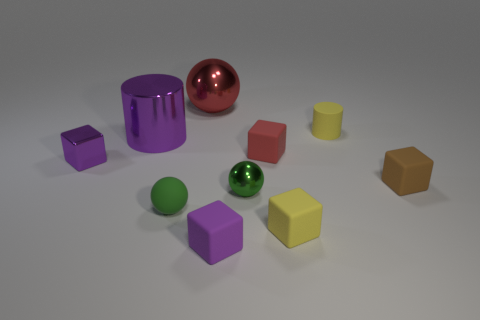What is the thing that is in front of the green rubber sphere and to the right of the red cube made of?
Provide a short and direct response. Rubber. Do the cylinder that is right of the large red metallic thing and the big shiny sphere have the same color?
Make the answer very short. No. Does the rubber cylinder have the same color as the large thing that is behind the small cylinder?
Ensure brevity in your answer.  No. There is a rubber ball; are there any red metal spheres in front of it?
Offer a very short reply. No. Do the small cylinder and the small brown object have the same material?
Your response must be concise. Yes. What material is the cylinder that is the same size as the brown matte thing?
Your answer should be compact. Rubber. How many things are either yellow matte objects that are behind the tiny brown object or large red metallic balls?
Your response must be concise. 2. Is the number of large red spheres behind the rubber ball the same as the number of cylinders?
Keep it short and to the point. No. Does the tiny cylinder have the same color as the big ball?
Your answer should be very brief. No. There is a metallic object that is both in front of the tiny yellow cylinder and right of the purple metallic cylinder; what is its color?
Your answer should be compact. Green. 